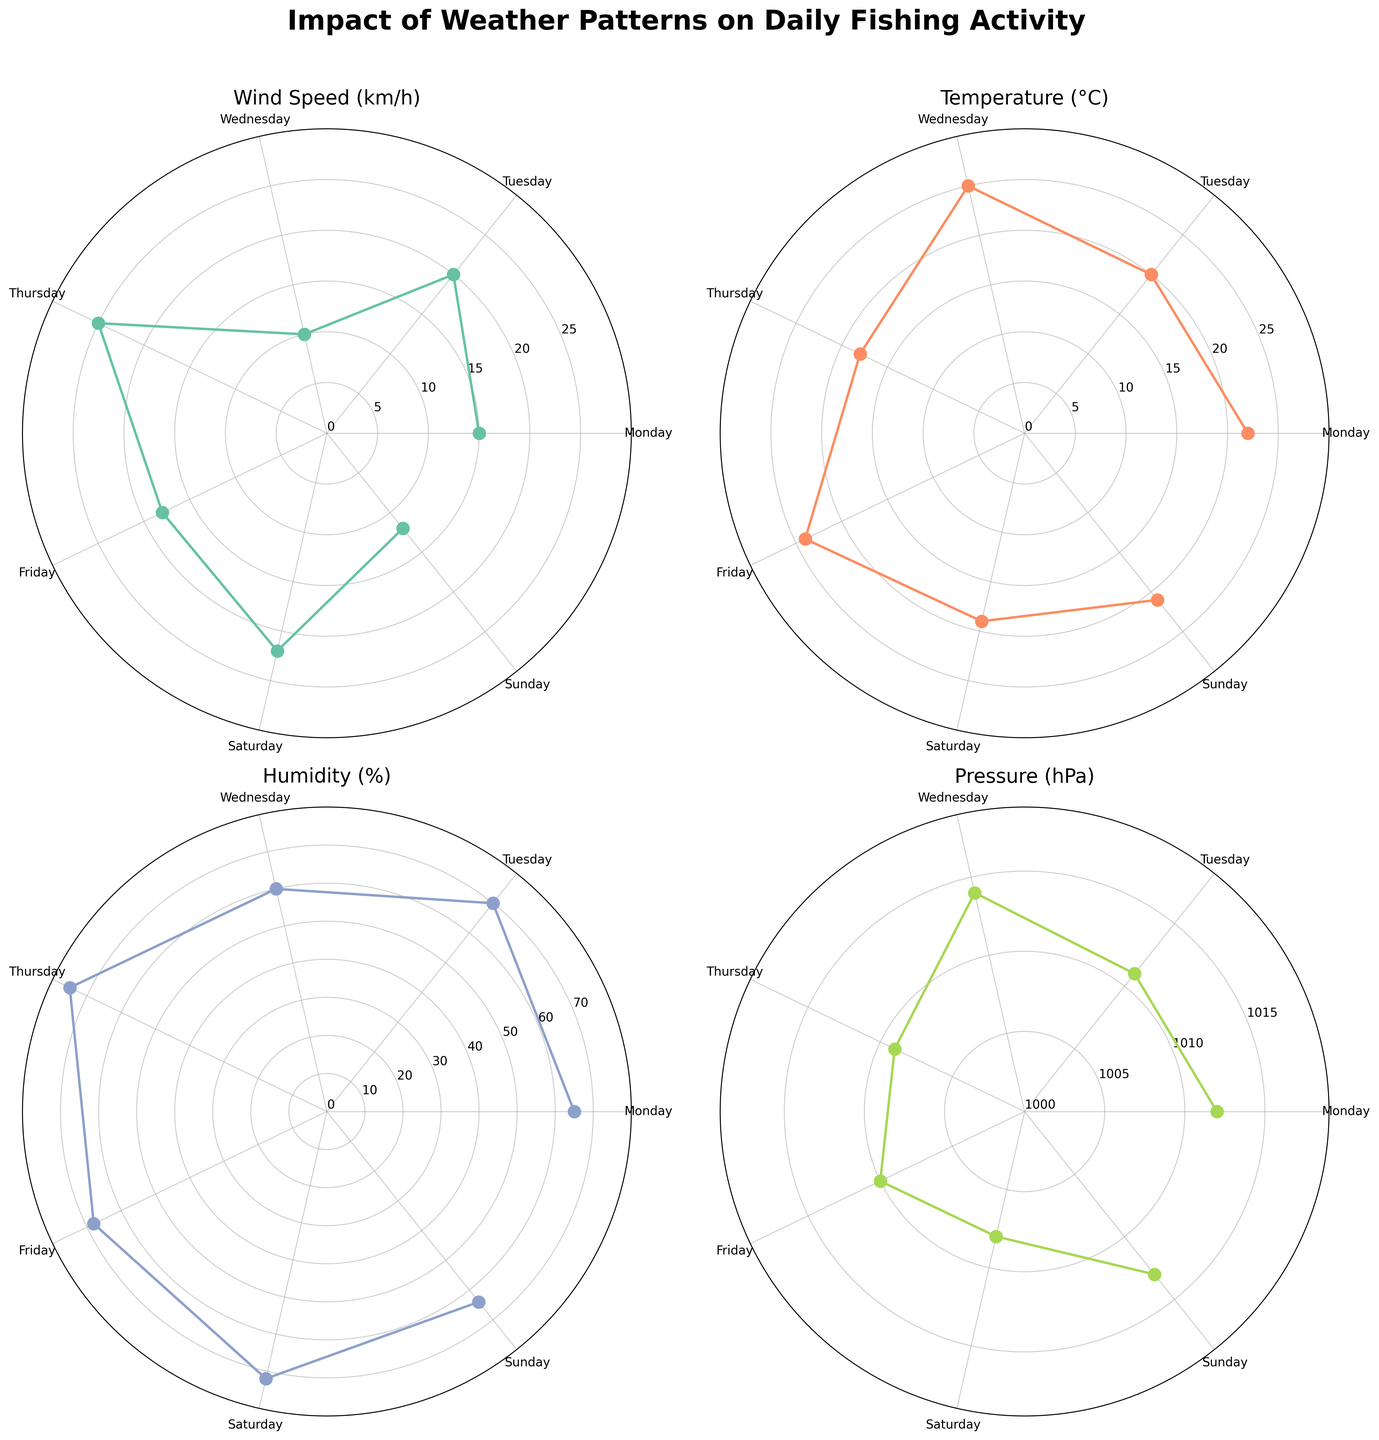what's the highest wind speed recorded during the week? Look at the Wind Speed subplot and identify the highest point on the radial axis. The highest value is observed on Thursday with a wind speed of 25 km/h.
Answer: 25 km/h what's the average temperature for the week? Check the Temperature subplot. The temperatures from Monday to Sunday are 22, 20, 25, 18, 24, 19, and 21°C respectively. The average temperature is (22 + 20 + 25 + 18 + 24 + 19 + 21) / 7 = 21.29°C.
Answer: 21.29°C which day has the highest humidity? Observe the Humidity subplot and identify the highest point. The highest value is recorded on Thursday with a humidity of 75%.
Answer: Thursday how does the pressure value on Saturday compare to that on Wednesday? Examine the Pressure subplot. The pressure on Saturday is 1008 hPa and on Wednesday is 1014 hPa. Saturday's pressure is 6 hPa lower than Wednesday's.
Answer: 6 hPa lower which weather variable shows the most significant variation throughout the week? Evaluate the range (difference between the highest and lowest values) for each subplot. Wind Speed varies from 10 to 25 km/h giving a range of 15 km/h. Temperature varies from 18 to 25°C giving a range of 7°C. Humidity varies from 60% to 75% giving a range of 15%. Pressure varies from 1008 to 1014 hPa giving a range of 6 hPa. The most significant variation is seen in Wind Speed with a range of 15 km/h.
Answer: Wind Speed what's the difference between the maximum and minimum pressure recorded? Check the Pressure subplot. The maximum pressure is 1014 hPa (Wednesday) and the minimum is 1008 hPa (Saturday). The difference is 1014 - 1008 = 6 hPa.
Answer: 6 hPa on which day is the wind speed the lowest? Observe the Wind Speed subplot and find the lowest point. The lowest wind speed is on Wednesday with 10 km/h.
Answer: Wednesday which day has both lower wind speed and pressure compared to Friday? Cross-reference the Wind Speed and Pressure subplots. Friday has a wind speed of 18 km/h and a pressure of 1010 hPa. Tuesday has a lower wind speed (20 km/h but less pressure) and Saturday has a lower wind speed (22 km/h but higher pressure). No single day fits entirely.
Answer: None 